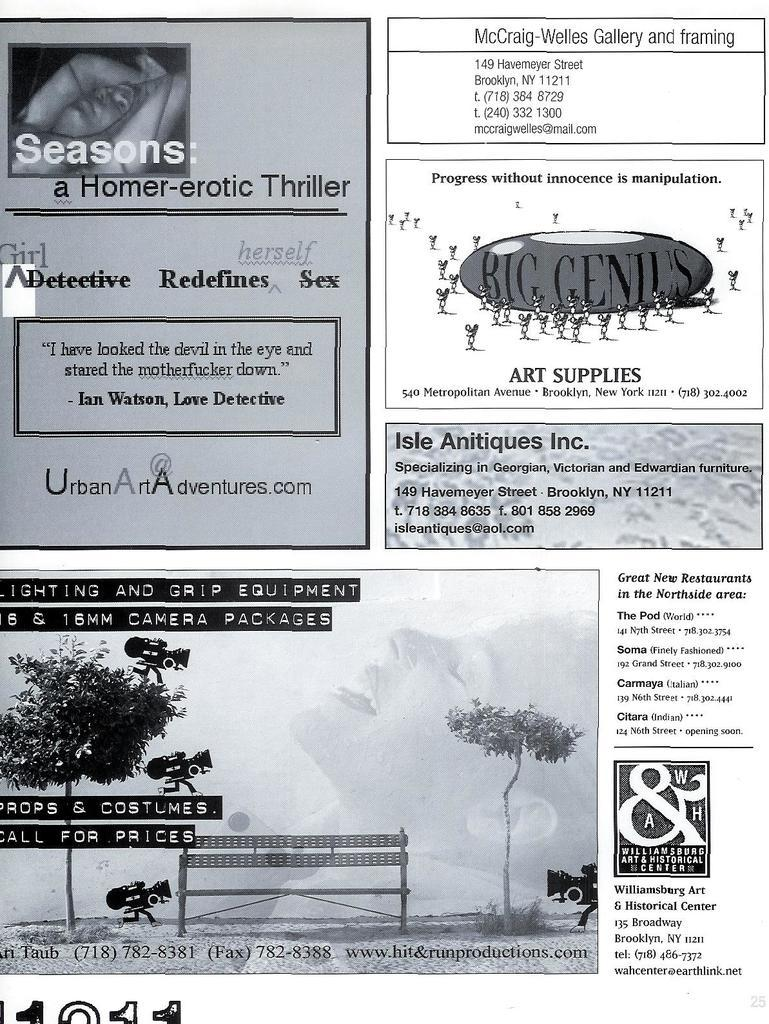What type of artwork is featured in the image? The image contains a collage. What kind of content is included in the collage? The collage includes pictures of advertisements. Are there any words or phrases associated with the advertisements? Yes, there is text associated with the advertisements in the collage. How many dresses are visible in the image? There are no dresses present in the image; it features a collage with advertisements. Can you tell me how much change is on the table in the image? There is no table or change present in the image; it features a collage with advertisements. 